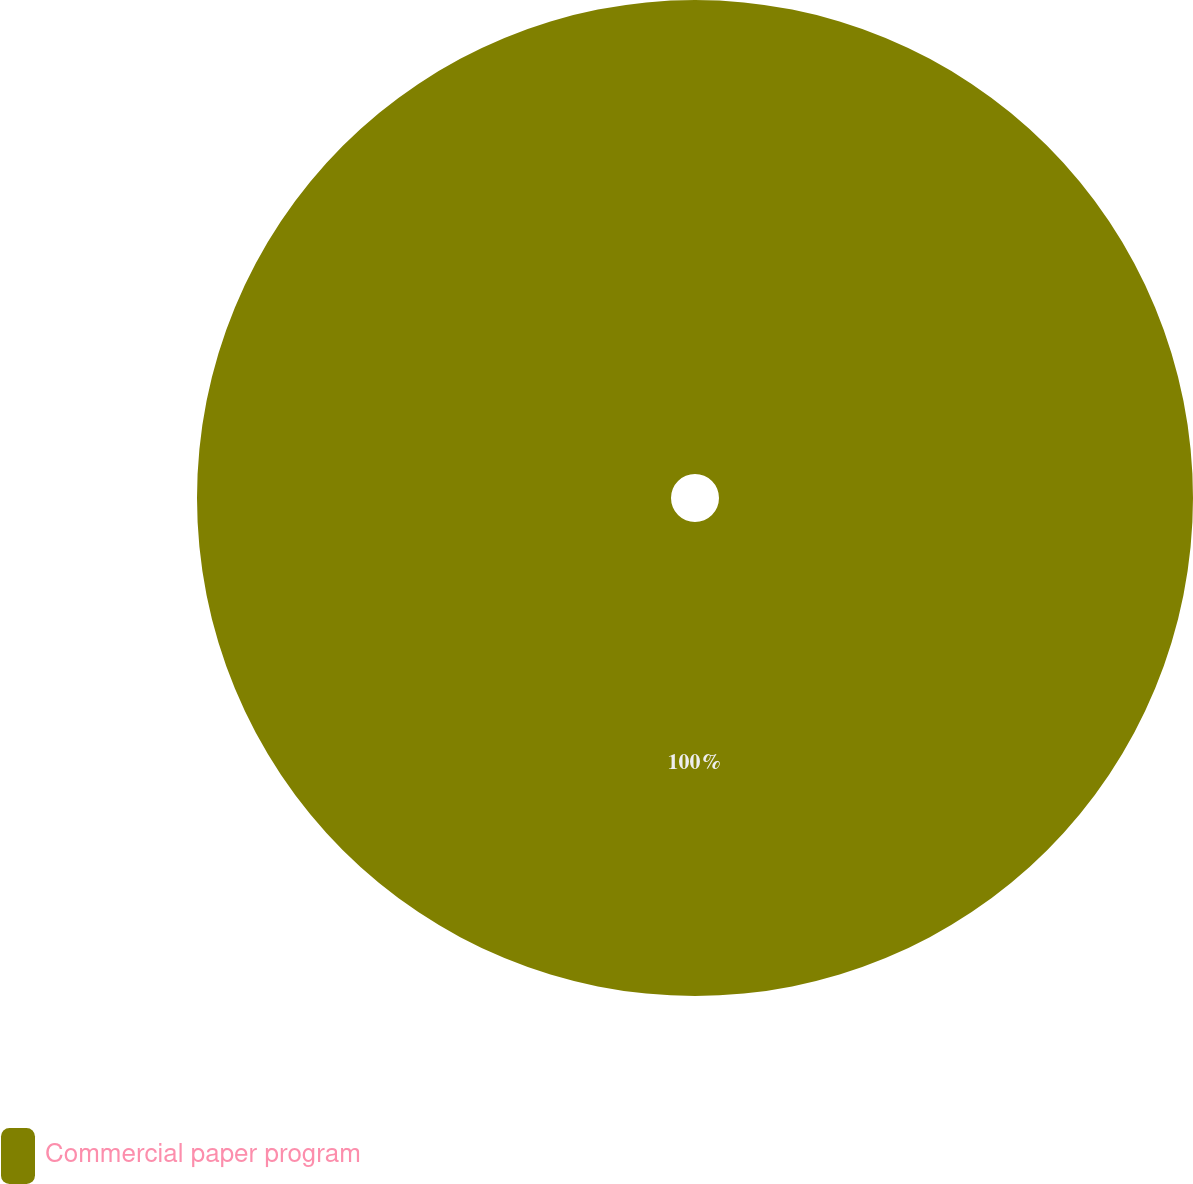<chart> <loc_0><loc_0><loc_500><loc_500><pie_chart><fcel>Commercial paper program<nl><fcel>100.0%<nl></chart> 